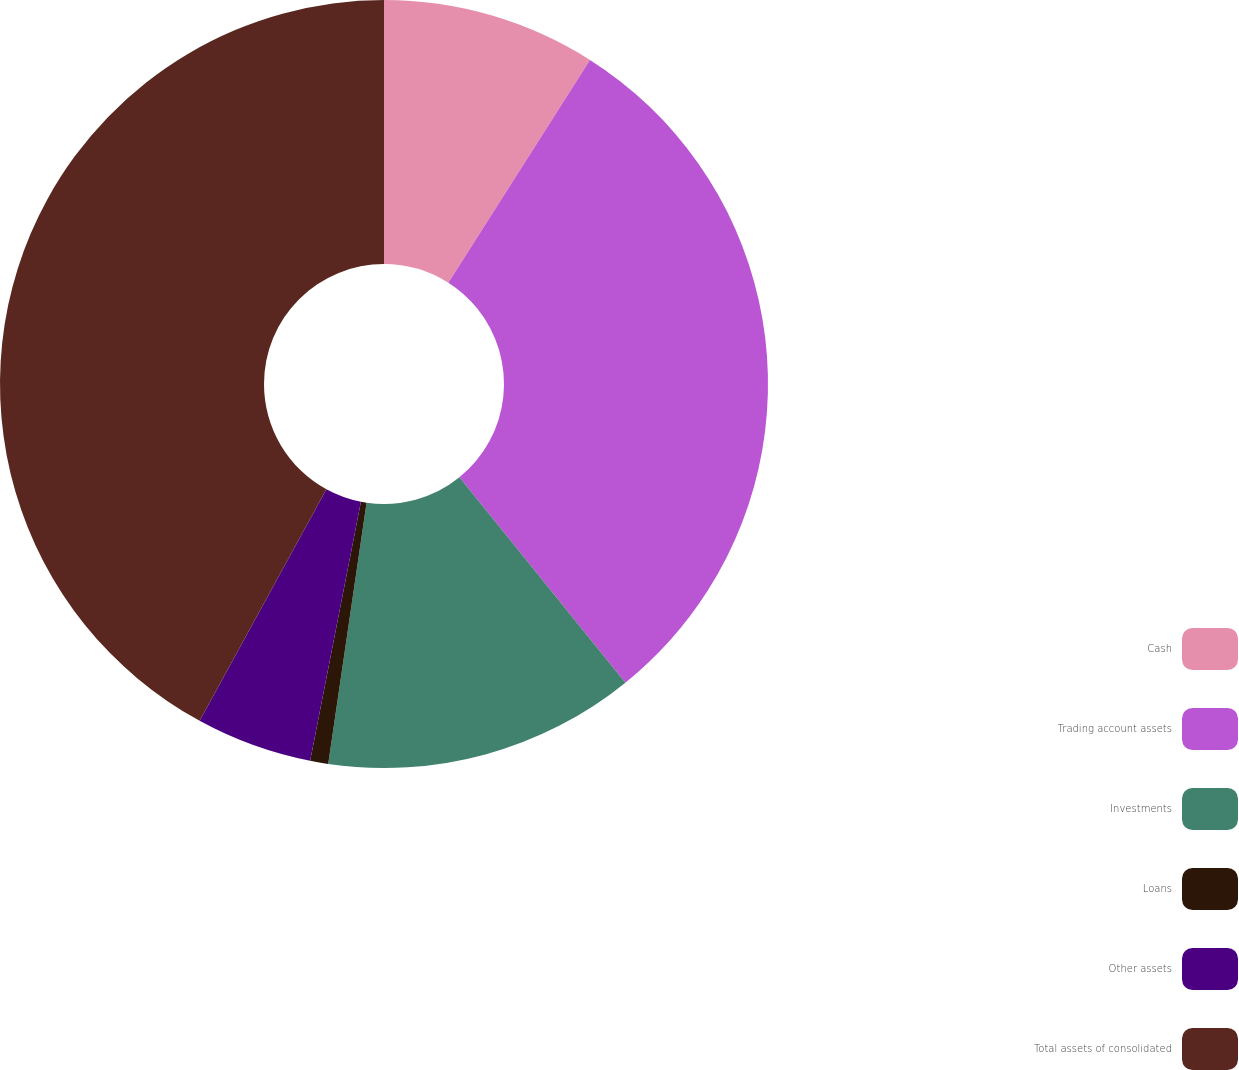Convert chart to OTSL. <chart><loc_0><loc_0><loc_500><loc_500><pie_chart><fcel>Cash<fcel>Trading account assets<fcel>Investments<fcel>Loans<fcel>Other assets<fcel>Total assets of consolidated<nl><fcel>9.01%<fcel>30.17%<fcel>13.14%<fcel>0.76%<fcel>4.89%<fcel>42.03%<nl></chart> 